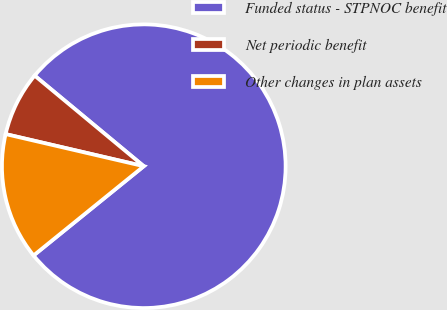Convert chart to OTSL. <chart><loc_0><loc_0><loc_500><loc_500><pie_chart><fcel>Funded status - STPNOC benefit<fcel>Net periodic benefit<fcel>Other changes in plan assets<nl><fcel>78.14%<fcel>7.39%<fcel>14.47%<nl></chart> 